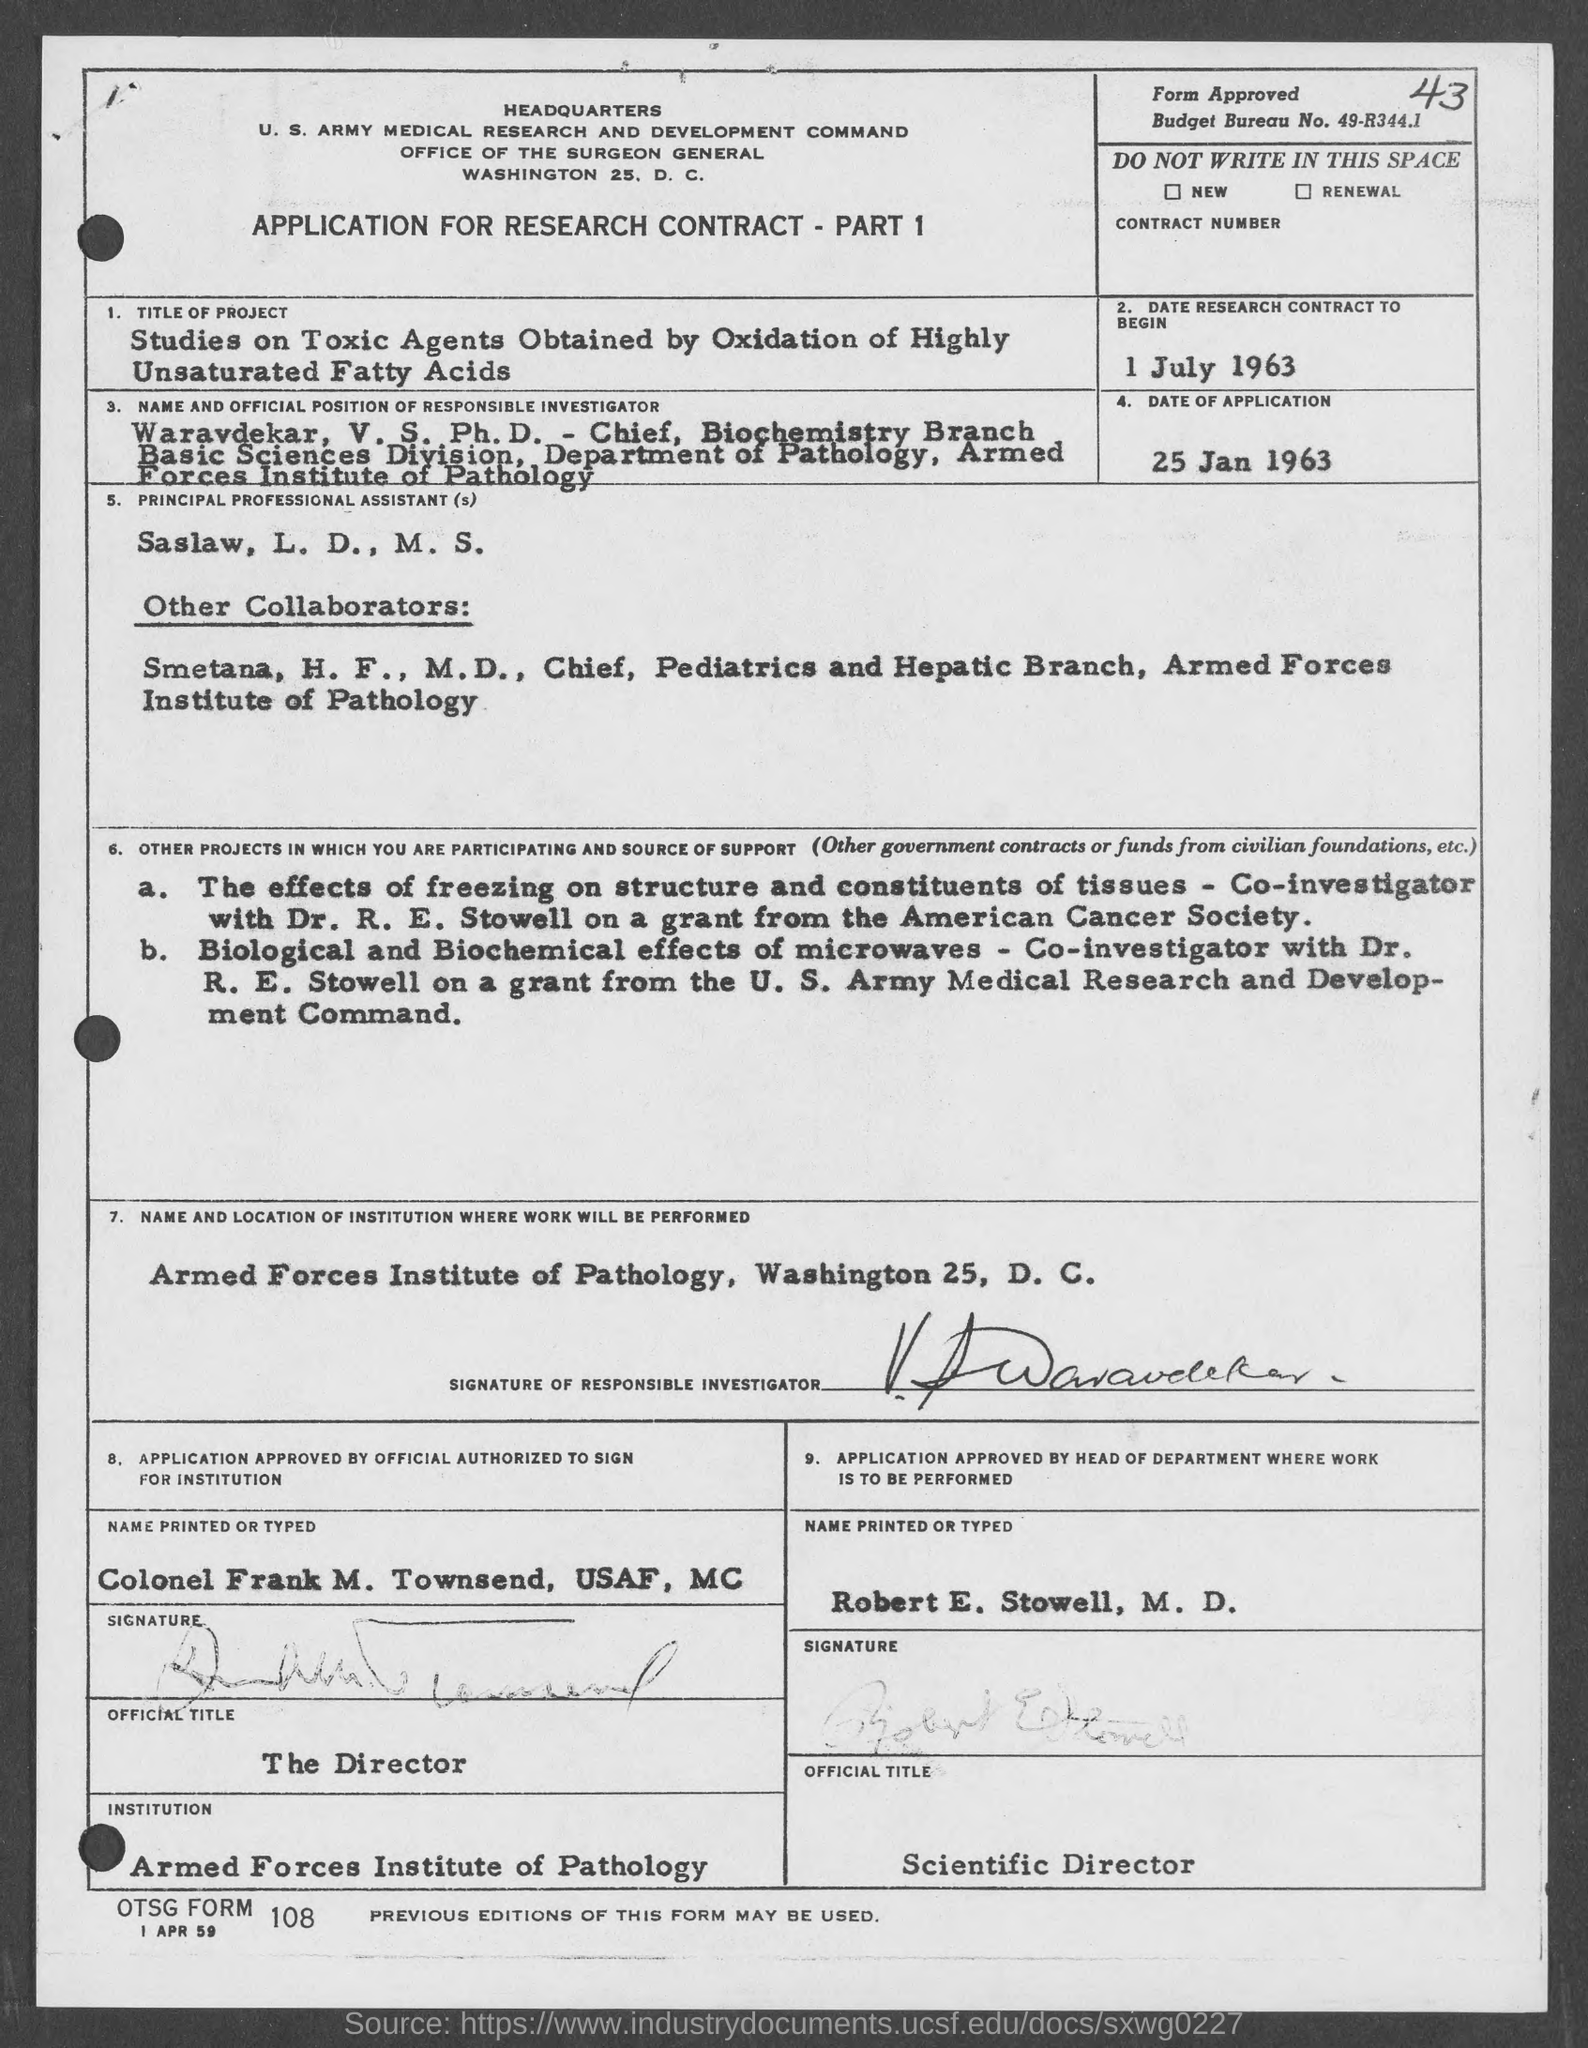Give some essential details in this illustration. The principal professional assistant, as per the application, is Saslaw, L. D., M.S. The application was submitted on January 25, 1963. The date of the research contract to begin is July 1, 1963. The name of the responsible investigator mentioned in the application is Waravdekar, V. S. Robert E. Stowell, M.D. holds the official title of Scientific Director. 